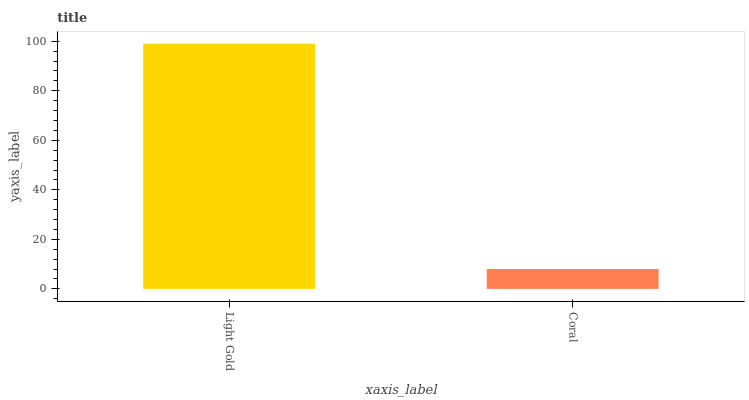Is Coral the minimum?
Answer yes or no. Yes. Is Light Gold the maximum?
Answer yes or no. Yes. Is Coral the maximum?
Answer yes or no. No. Is Light Gold greater than Coral?
Answer yes or no. Yes. Is Coral less than Light Gold?
Answer yes or no. Yes. Is Coral greater than Light Gold?
Answer yes or no. No. Is Light Gold less than Coral?
Answer yes or no. No. Is Light Gold the high median?
Answer yes or no. Yes. Is Coral the low median?
Answer yes or no. Yes. Is Coral the high median?
Answer yes or no. No. Is Light Gold the low median?
Answer yes or no. No. 